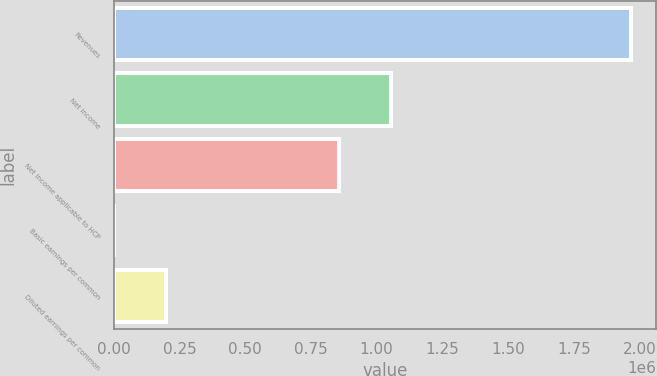Convert chart to OTSL. <chart><loc_0><loc_0><loc_500><loc_500><bar_chart><fcel>Revenues<fcel>Net income<fcel>Net income applicable to HCP<fcel>Basic earnings per common<fcel>Diluted earnings per common<nl><fcel>1.9663e+06<fcel>1.05313e+06<fcel>856500<fcel>1.88<fcel>196632<nl></chart> 